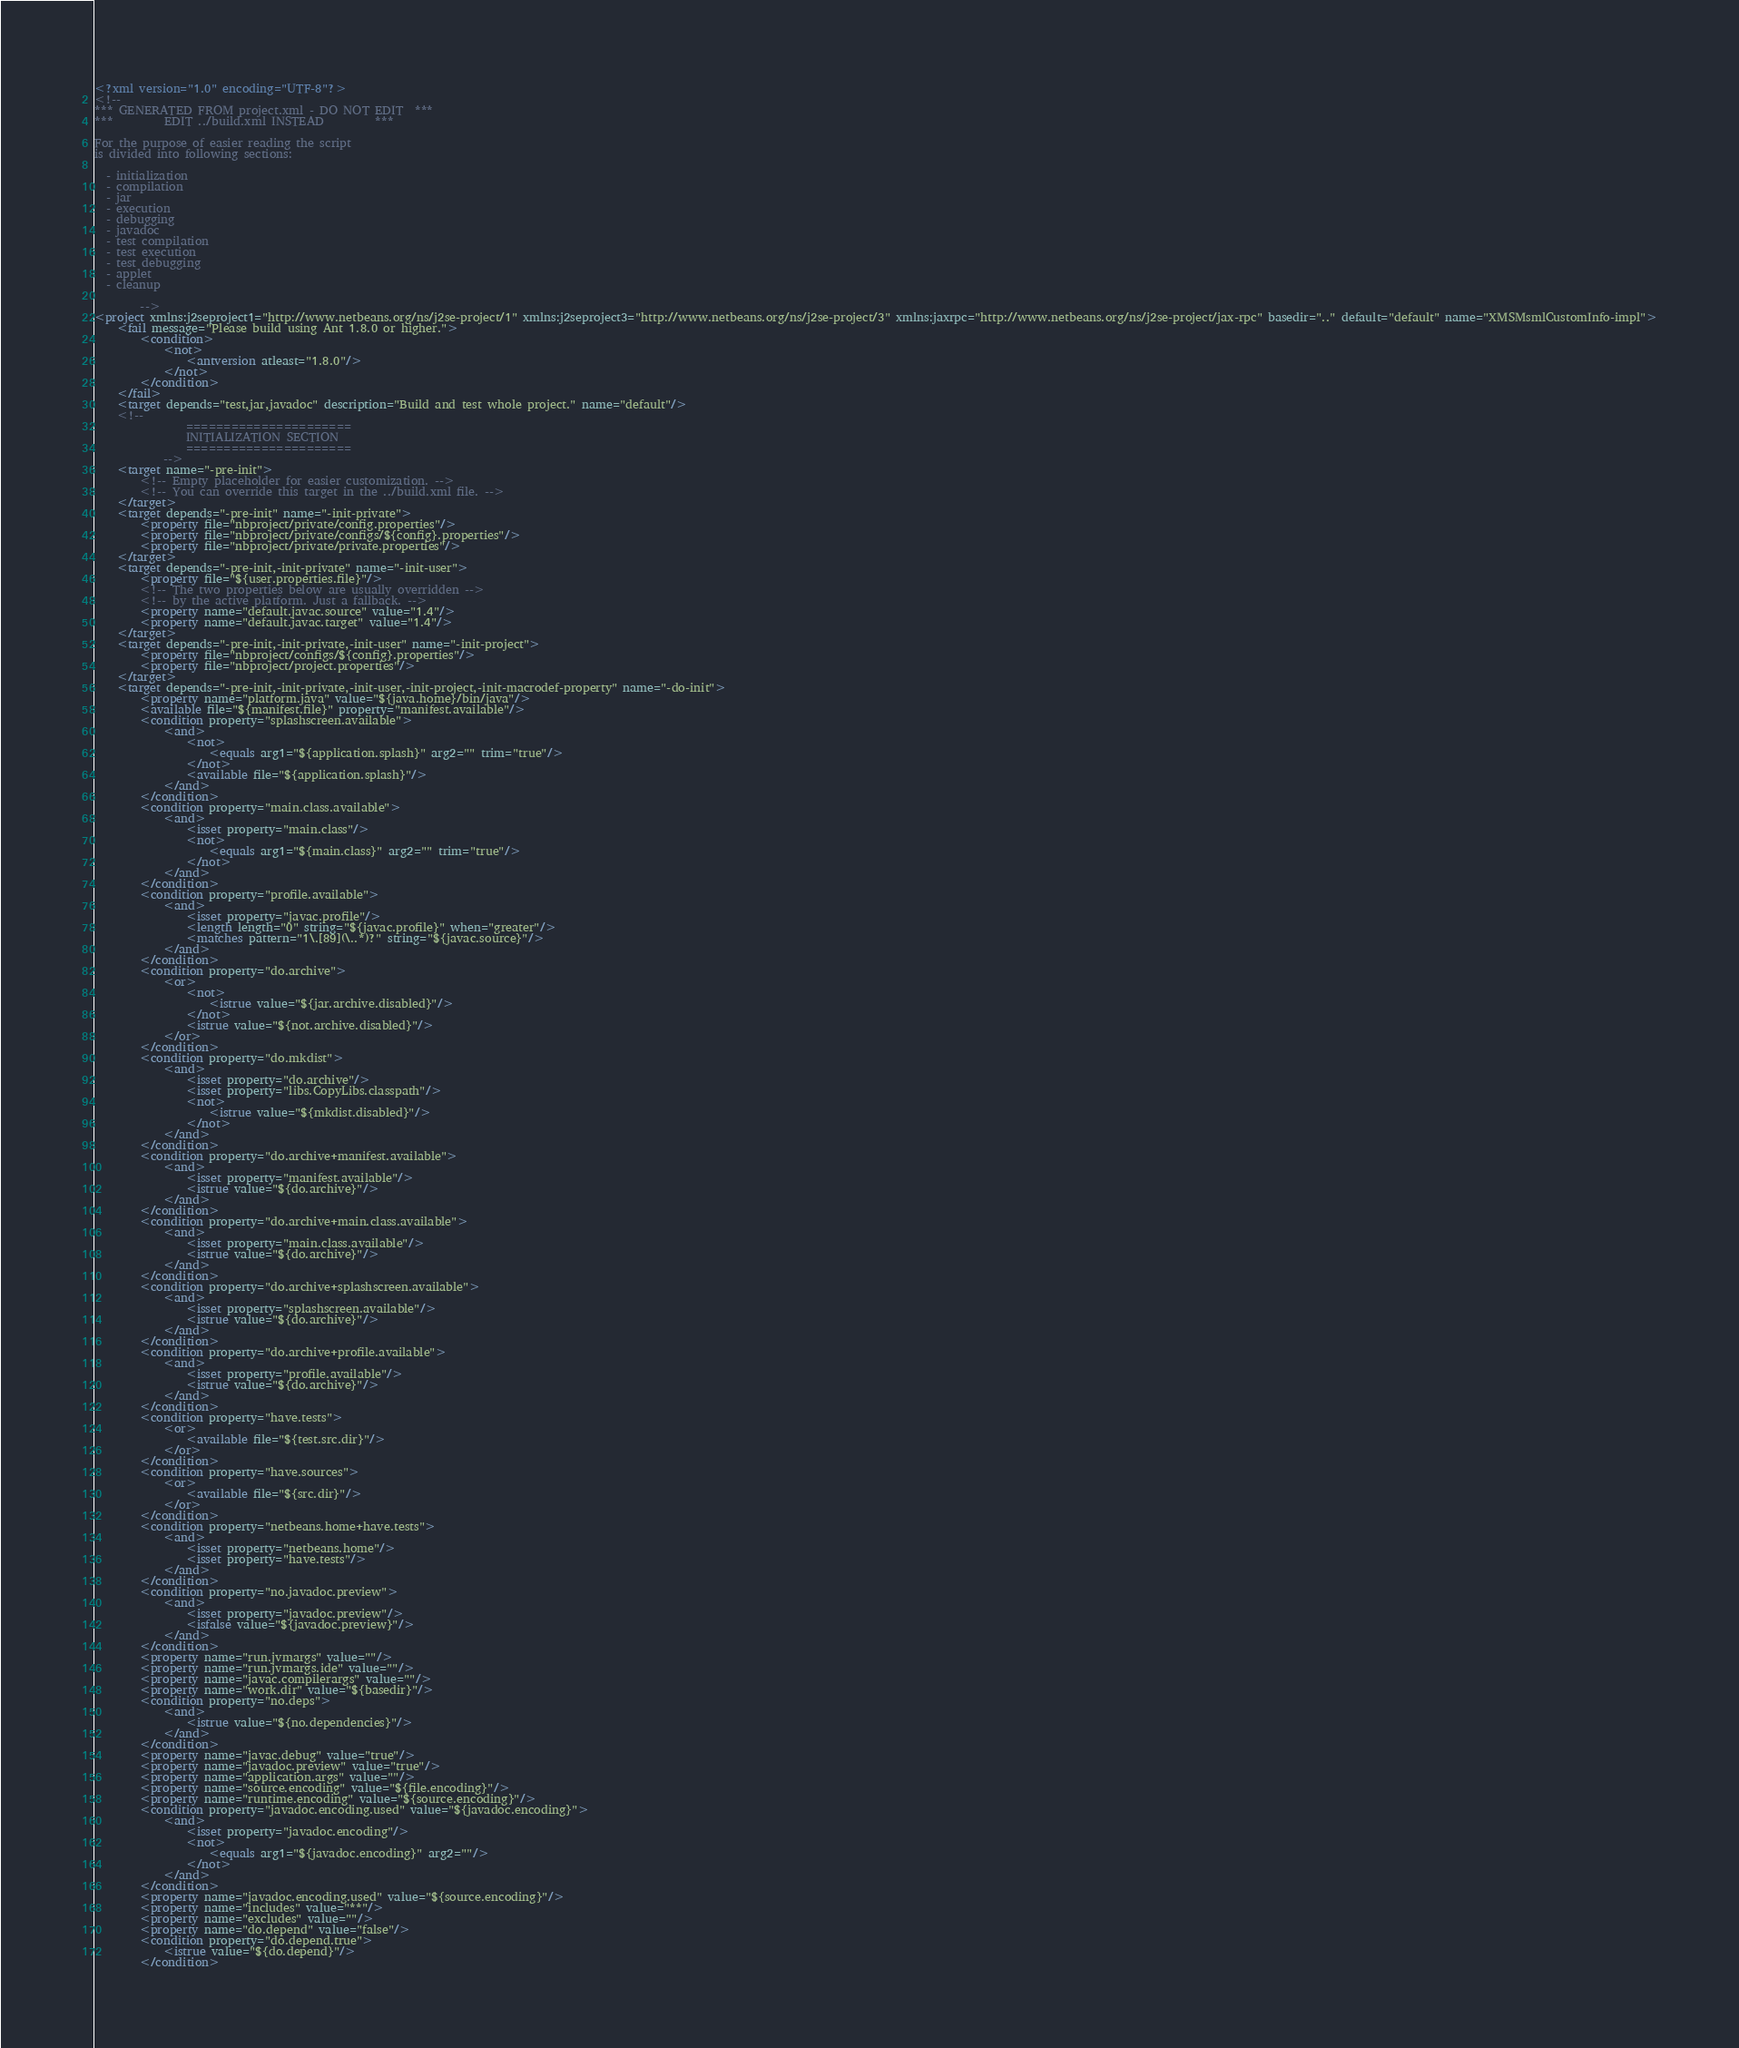<code> <loc_0><loc_0><loc_500><loc_500><_XML_><?xml version="1.0" encoding="UTF-8"?>
<!--
*** GENERATED FROM project.xml - DO NOT EDIT  ***
***         EDIT ../build.xml INSTEAD         ***

For the purpose of easier reading the script
is divided into following sections:

  - initialization
  - compilation
  - jar
  - execution
  - debugging
  - javadoc
  - test compilation
  - test execution
  - test debugging
  - applet
  - cleanup

        -->
<project xmlns:j2seproject1="http://www.netbeans.org/ns/j2se-project/1" xmlns:j2seproject3="http://www.netbeans.org/ns/j2se-project/3" xmlns:jaxrpc="http://www.netbeans.org/ns/j2se-project/jax-rpc" basedir=".." default="default" name="XMSMsmlCustomInfo-impl">
    <fail message="Please build using Ant 1.8.0 or higher.">
        <condition>
            <not>
                <antversion atleast="1.8.0"/>
            </not>
        </condition>
    </fail>
    <target depends="test,jar,javadoc" description="Build and test whole project." name="default"/>
    <!-- 
                ======================
                INITIALIZATION SECTION 
                ======================
            -->
    <target name="-pre-init">
        <!-- Empty placeholder for easier customization. -->
        <!-- You can override this target in the ../build.xml file. -->
    </target>
    <target depends="-pre-init" name="-init-private">
        <property file="nbproject/private/config.properties"/>
        <property file="nbproject/private/configs/${config}.properties"/>
        <property file="nbproject/private/private.properties"/>
    </target>
    <target depends="-pre-init,-init-private" name="-init-user">
        <property file="${user.properties.file}"/>
        <!-- The two properties below are usually overridden -->
        <!-- by the active platform. Just a fallback. -->
        <property name="default.javac.source" value="1.4"/>
        <property name="default.javac.target" value="1.4"/>
    </target>
    <target depends="-pre-init,-init-private,-init-user" name="-init-project">
        <property file="nbproject/configs/${config}.properties"/>
        <property file="nbproject/project.properties"/>
    </target>
    <target depends="-pre-init,-init-private,-init-user,-init-project,-init-macrodef-property" name="-do-init">
        <property name="platform.java" value="${java.home}/bin/java"/>
        <available file="${manifest.file}" property="manifest.available"/>
        <condition property="splashscreen.available">
            <and>
                <not>
                    <equals arg1="${application.splash}" arg2="" trim="true"/>
                </not>
                <available file="${application.splash}"/>
            </and>
        </condition>
        <condition property="main.class.available">
            <and>
                <isset property="main.class"/>
                <not>
                    <equals arg1="${main.class}" arg2="" trim="true"/>
                </not>
            </and>
        </condition>
        <condition property="profile.available">
            <and>
                <isset property="javac.profile"/>
                <length length="0" string="${javac.profile}" when="greater"/>
                <matches pattern="1\.[89](\..*)?" string="${javac.source}"/>
            </and>
        </condition>
        <condition property="do.archive">
            <or>
                <not>
                    <istrue value="${jar.archive.disabled}"/>
                </not>
                <istrue value="${not.archive.disabled}"/>
            </or>
        </condition>
        <condition property="do.mkdist">
            <and>
                <isset property="do.archive"/>
                <isset property="libs.CopyLibs.classpath"/>
                <not>
                    <istrue value="${mkdist.disabled}"/>
                </not>
            </and>
        </condition>
        <condition property="do.archive+manifest.available">
            <and>
                <isset property="manifest.available"/>
                <istrue value="${do.archive}"/>
            </and>
        </condition>
        <condition property="do.archive+main.class.available">
            <and>
                <isset property="main.class.available"/>
                <istrue value="${do.archive}"/>
            </and>
        </condition>
        <condition property="do.archive+splashscreen.available">
            <and>
                <isset property="splashscreen.available"/>
                <istrue value="${do.archive}"/>
            </and>
        </condition>
        <condition property="do.archive+profile.available">
            <and>
                <isset property="profile.available"/>
                <istrue value="${do.archive}"/>
            </and>
        </condition>
        <condition property="have.tests">
            <or>
                <available file="${test.src.dir}"/>
            </or>
        </condition>
        <condition property="have.sources">
            <or>
                <available file="${src.dir}"/>
            </or>
        </condition>
        <condition property="netbeans.home+have.tests">
            <and>
                <isset property="netbeans.home"/>
                <isset property="have.tests"/>
            </and>
        </condition>
        <condition property="no.javadoc.preview">
            <and>
                <isset property="javadoc.preview"/>
                <isfalse value="${javadoc.preview}"/>
            </and>
        </condition>
        <property name="run.jvmargs" value=""/>
        <property name="run.jvmargs.ide" value=""/>
        <property name="javac.compilerargs" value=""/>
        <property name="work.dir" value="${basedir}"/>
        <condition property="no.deps">
            <and>
                <istrue value="${no.dependencies}"/>
            </and>
        </condition>
        <property name="javac.debug" value="true"/>
        <property name="javadoc.preview" value="true"/>
        <property name="application.args" value=""/>
        <property name="source.encoding" value="${file.encoding}"/>
        <property name="runtime.encoding" value="${source.encoding}"/>
        <condition property="javadoc.encoding.used" value="${javadoc.encoding}">
            <and>
                <isset property="javadoc.encoding"/>
                <not>
                    <equals arg1="${javadoc.encoding}" arg2=""/>
                </not>
            </and>
        </condition>
        <property name="javadoc.encoding.used" value="${source.encoding}"/>
        <property name="includes" value="**"/>
        <property name="excludes" value=""/>
        <property name="do.depend" value="false"/>
        <condition property="do.depend.true">
            <istrue value="${do.depend}"/>
        </condition></code> 